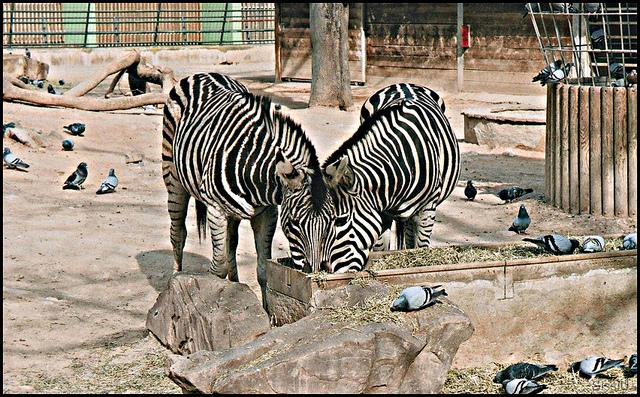How many zebras are eating hay from the trough? two 